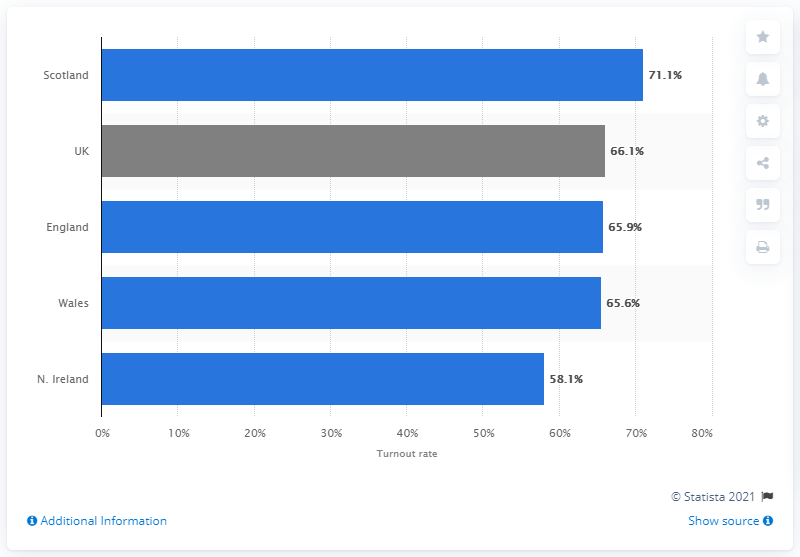Specify some key components in this picture. Scotland had the highest voter turnout rate among all regions. 